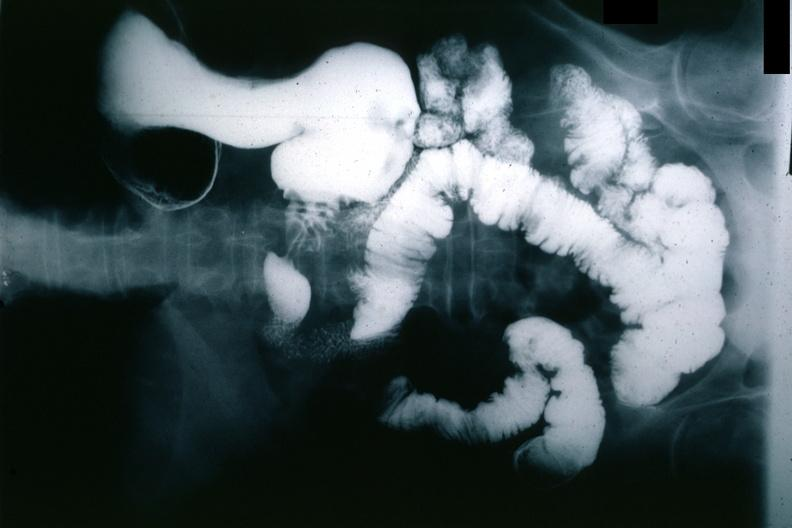what does this image show?
Answer the question using a single word or phrase. X-ray barium study gastric polyp 